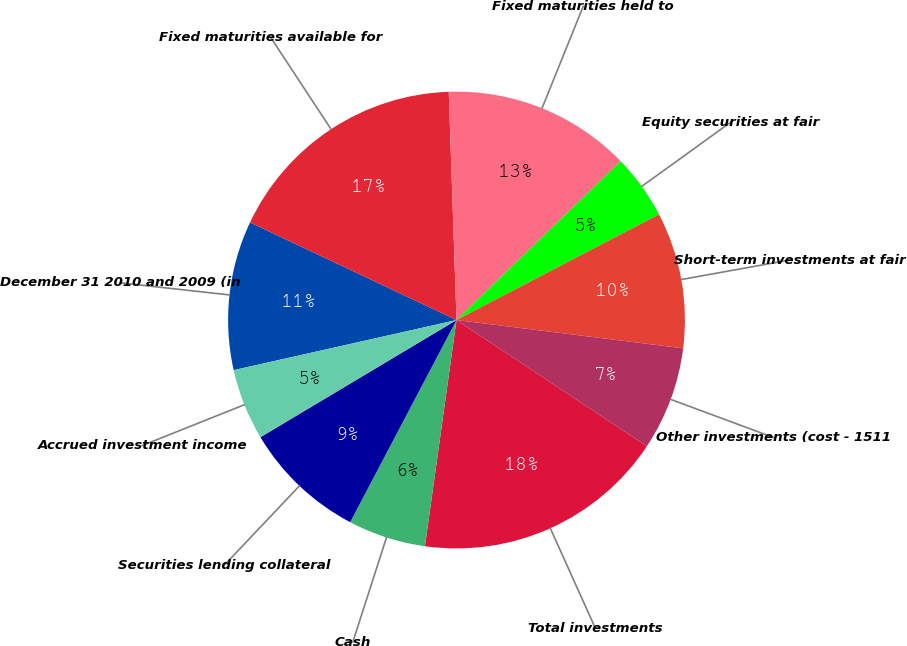Convert chart to OTSL. <chart><loc_0><loc_0><loc_500><loc_500><pie_chart><fcel>December 31 2010 and 2009 (in<fcel>Fixed maturities available for<fcel>Fixed maturities held to<fcel>Equity securities at fair<fcel>Short-term investments at fair<fcel>Other investments (cost - 1511<fcel>Total investments<fcel>Cash<fcel>Securities lending collateral<fcel>Accrued investment income<nl><fcel>10.55%<fcel>17.43%<fcel>13.3%<fcel>4.59%<fcel>9.63%<fcel>7.34%<fcel>17.89%<fcel>5.5%<fcel>8.72%<fcel>5.05%<nl></chart> 